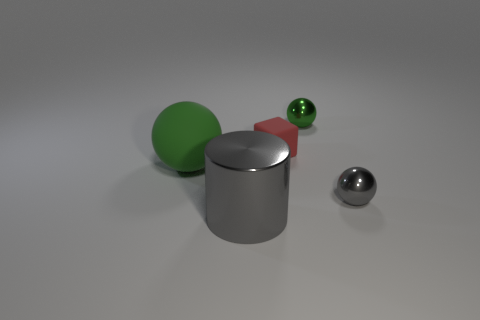Subtract 1 balls. How many balls are left? 2 Add 3 small things. How many objects exist? 8 Subtract all cubes. How many objects are left? 4 Add 2 big brown shiny blocks. How many big brown shiny blocks exist? 2 Subtract 0 green blocks. How many objects are left? 5 Subtract all large brown objects. Subtract all tiny green metallic spheres. How many objects are left? 4 Add 4 large metallic cylinders. How many large metallic cylinders are left? 5 